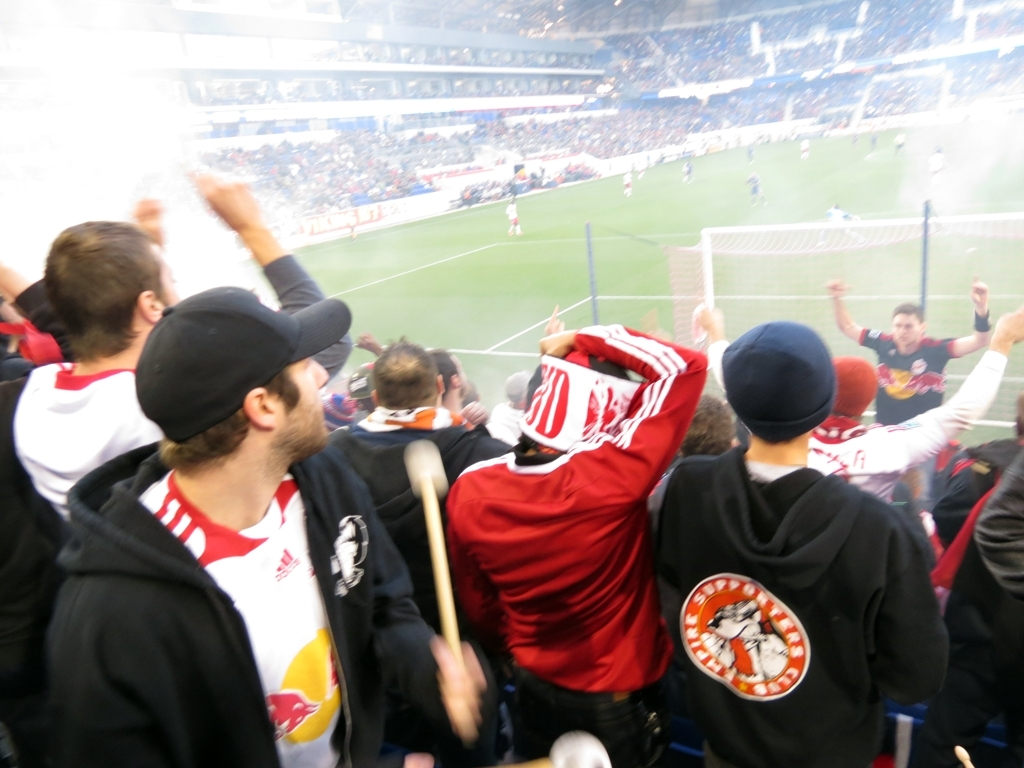What emotions are being conveyed by the people in the image? The people in the image appear to be filled with excitement and passion. Their raised arms, clenched fists, and ardent gestures suggest they are cheering, which conveys a strong sense of collective joy and anticipation, typical of fans supporting their team at a significant point in a match. 